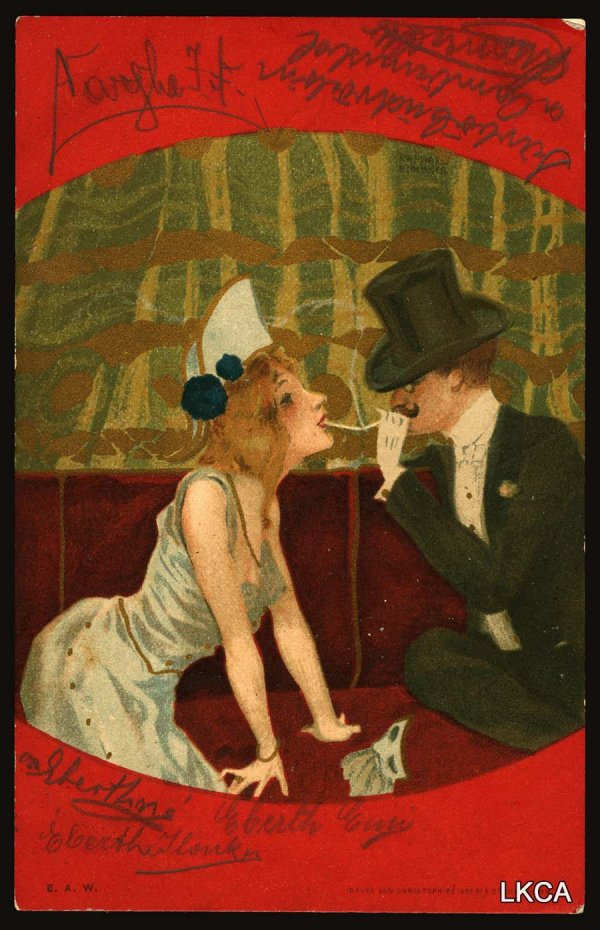What kind of music do you think would be playing in this scene? A serene and melodic classical piece would be perfect for this scene. Perhaps a gentle piano sonata by Debussy or a romantic violin concerto by Mendelssohn. The music would encapsulate the warmth and intimacy shared between the man and woman, adding depth to the romantic ambiance. 